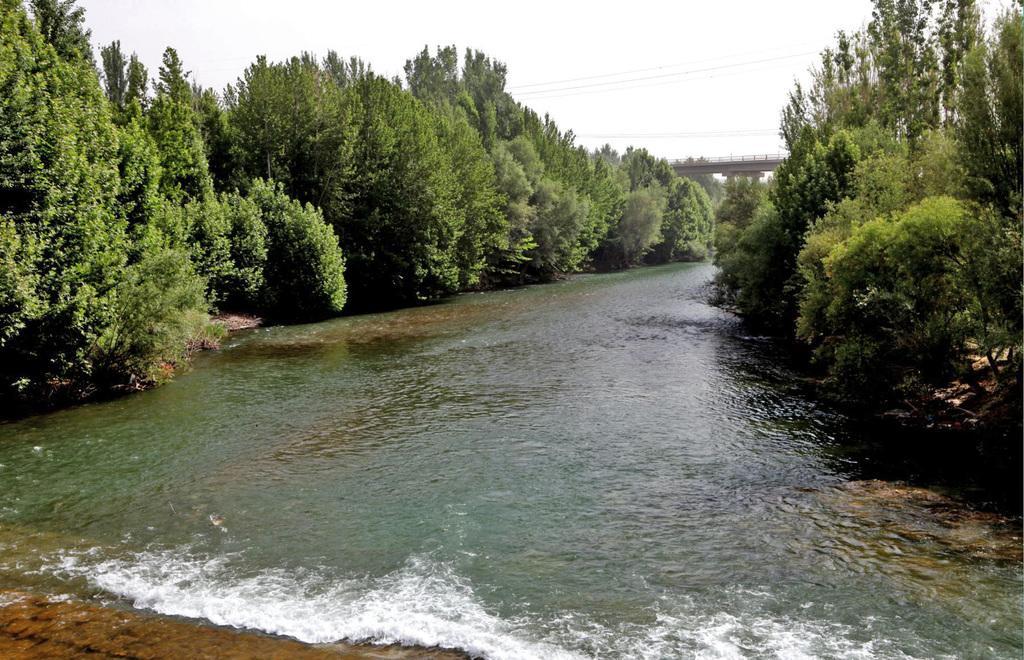Can you describe this image briefly? At the center of the image there is a river. On the either sides of the river there are trees. In the background there is a bridge and a sky. 